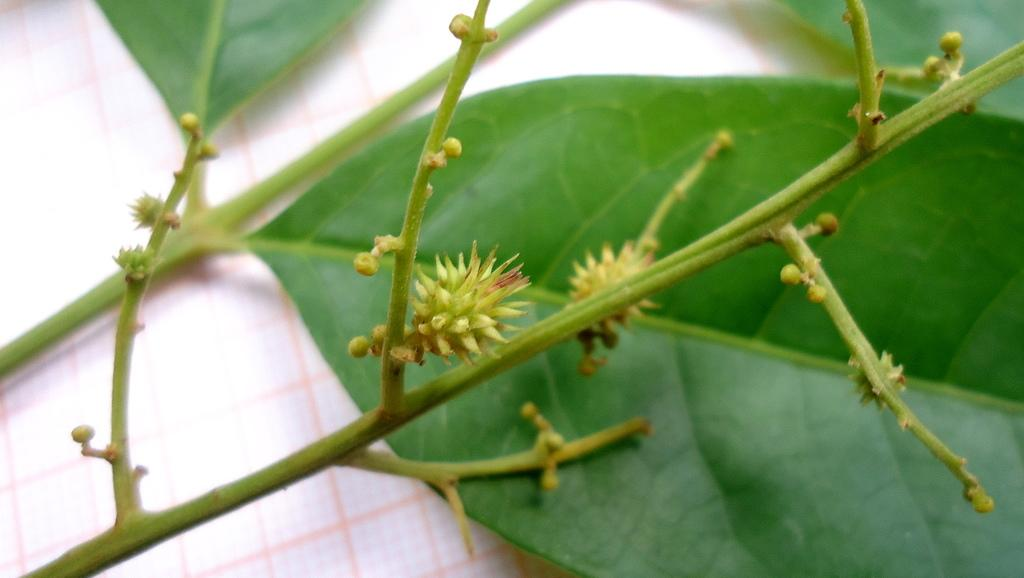What type of plant material can be seen in the image? There are green leaves, stems, and buds in the image. Can you describe the growth stage of the plants in the image? The presence of buds suggests that the plants are in the process of blooming or growing. What color are the leaves in the image? The leaves in the image are green. How many pizzas can be seen in the image? There are no pizzas present in the image. What type of animal is grazing on the plants in the image? There are no animals present in the image, including yaks or giraffes. 